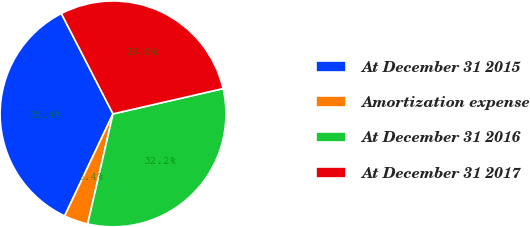<chart> <loc_0><loc_0><loc_500><loc_500><pie_chart><fcel>At December 31 2015<fcel>Amortization expense<fcel>At December 31 2016<fcel>At December 31 2017<nl><fcel>35.39%<fcel>3.45%<fcel>32.2%<fcel>28.97%<nl></chart> 